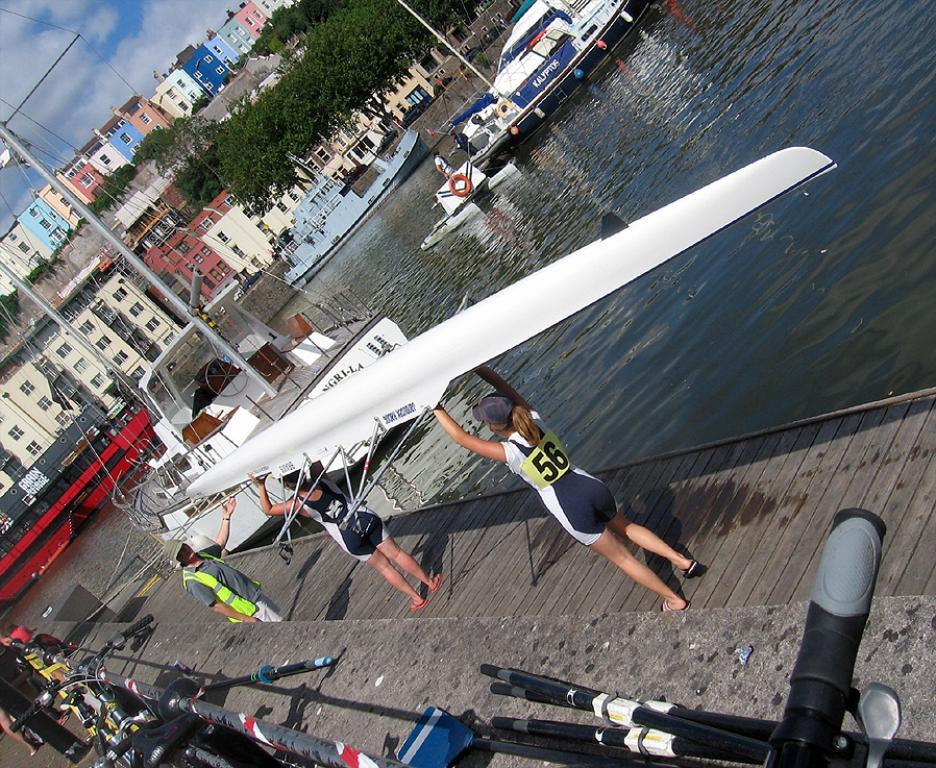<image>
Share a concise interpretation of the image provided. A lady wearing the number 56 is carrying a kayak. 